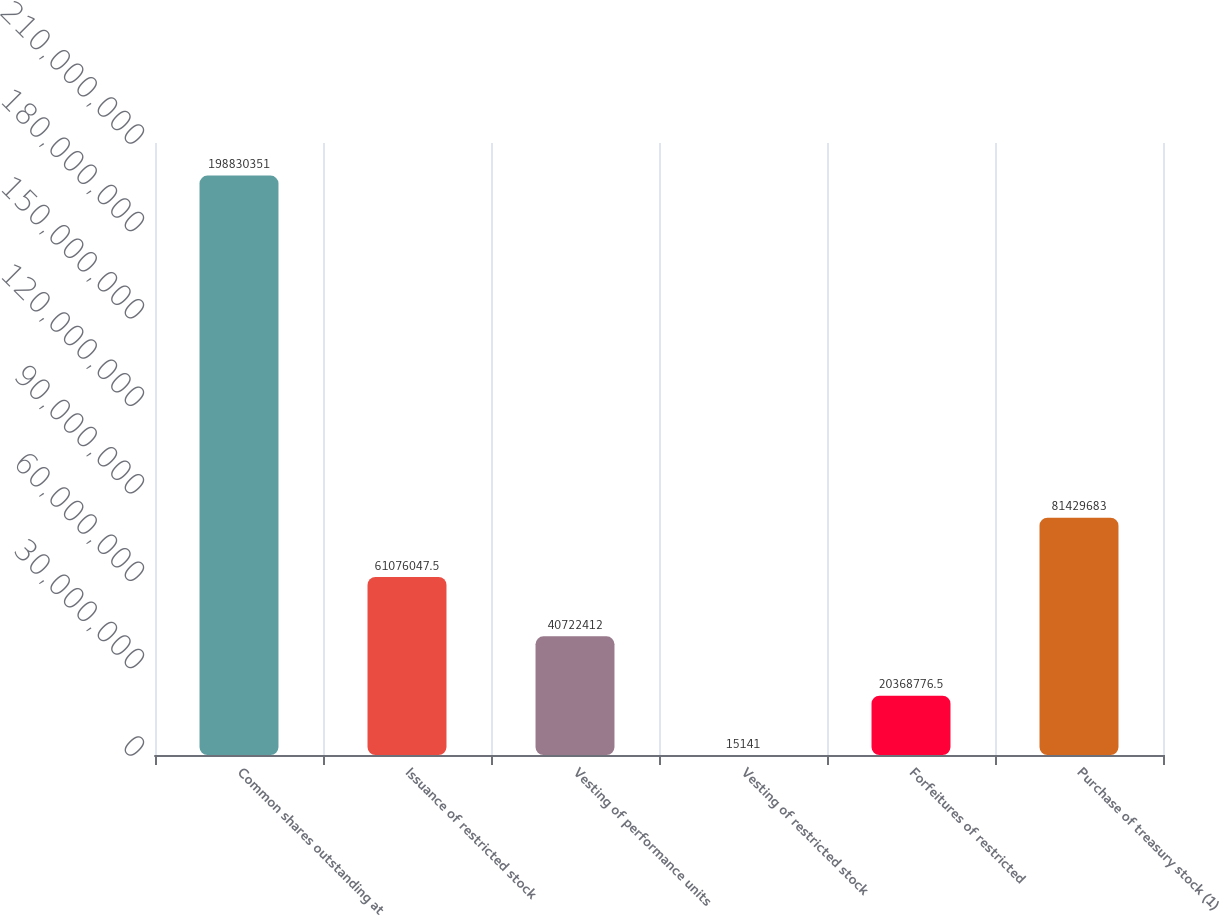Convert chart. <chart><loc_0><loc_0><loc_500><loc_500><bar_chart><fcel>Common shares outstanding at<fcel>Issuance of restricted stock<fcel>Vesting of performance units<fcel>Vesting of restricted stock<fcel>Forfeitures of restricted<fcel>Purchase of treasury stock (1)<nl><fcel>1.9883e+08<fcel>6.1076e+07<fcel>4.07224e+07<fcel>15141<fcel>2.03688e+07<fcel>8.14297e+07<nl></chart> 